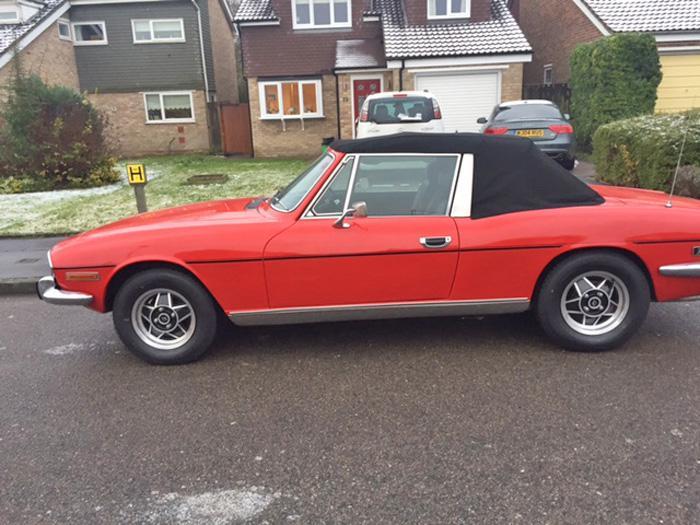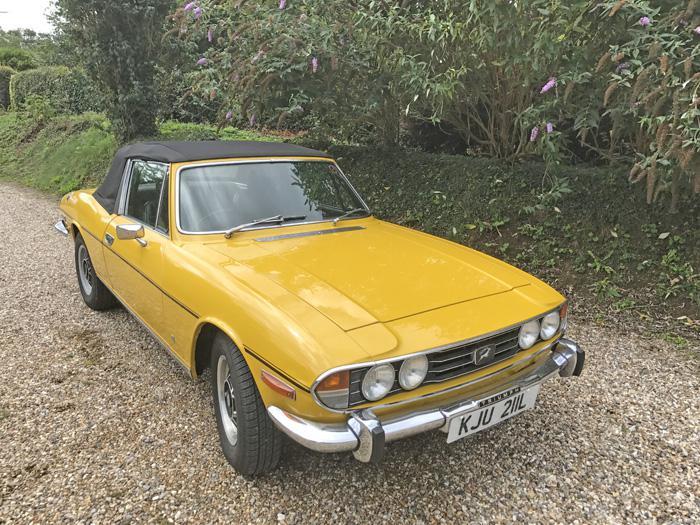The first image is the image on the left, the second image is the image on the right. Evaluate the accuracy of this statement regarding the images: "There are two yellow cars parked on grass.". Is it true? Answer yes or no. No. The first image is the image on the left, the second image is the image on the right. Evaluate the accuracy of this statement regarding the images: "An image shows a horizontal parked red convertible with its black top covering it.". Is it true? Answer yes or no. Yes. 